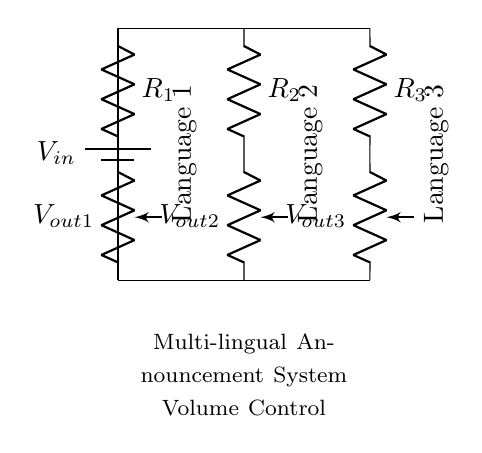What is the input voltage labeled as? The input voltage is represented by the label "V_in", which is placed next to the battery component in the circuit.
Answer: V_in What are the resistors used in this voltage divider? The circuit contains three resistors labeled as R_1, R_2, and R_3, each connected in series with the voltage outputs for different languages.
Answer: R_1, R_2, R_3 How many language outputs are provided in the circuit? The circuit diagram shows three language outputs, indicated by labels for each potentiometer corresponding to the languages.
Answer: Three Which component controls the volume for each language? The volume for each language is controlled by a potentiometer, which allows for adjustable resistance and thus variable output voltage.
Answer: Potentiometr What is the function of the voltage divider in this circuit? The voltage divider in this circuit allows for adjusting the output voltages for multi-lingual announcements, providing individual volume control for each language output.
Answer: Volume control If R_1 is 1k ohm, R_2 is 2k ohm, and R_3 is 3k ohm, what is the total resistance? The total resistance in the series can be calculated by adding the resistances together: 1k + 2k + 3k equals 6k ohms.
Answer: 6k ohm Which language output is found in the middle position of the circuit? The middle position of the circuit corresponds to R_2, which is designated for Language 2, as it is located between R_1 and R_3 in the arrangement.
Answer: Language 2 